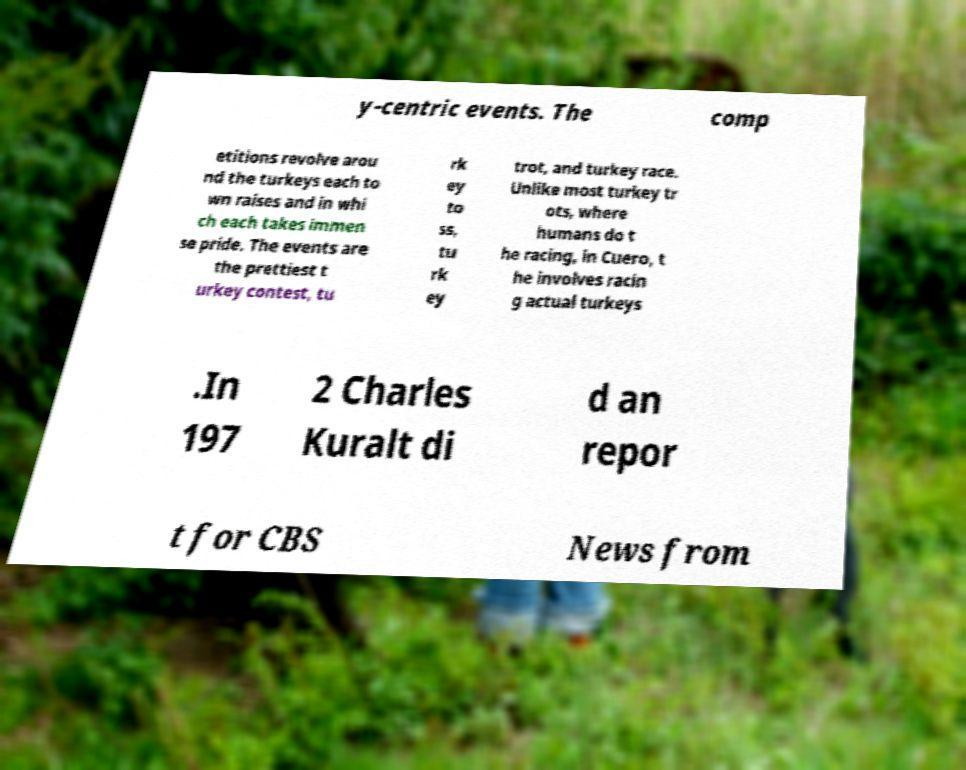For documentation purposes, I need the text within this image transcribed. Could you provide that? y-centric events. The comp etitions revolve arou nd the turkeys each to wn raises and in whi ch each takes immen se pride. The events are the prettiest t urkey contest, tu rk ey to ss, tu rk ey trot, and turkey race. Unlike most turkey tr ots, where humans do t he racing, in Cuero, t he involves racin g actual turkeys .In 197 2 Charles Kuralt di d an repor t for CBS News from 